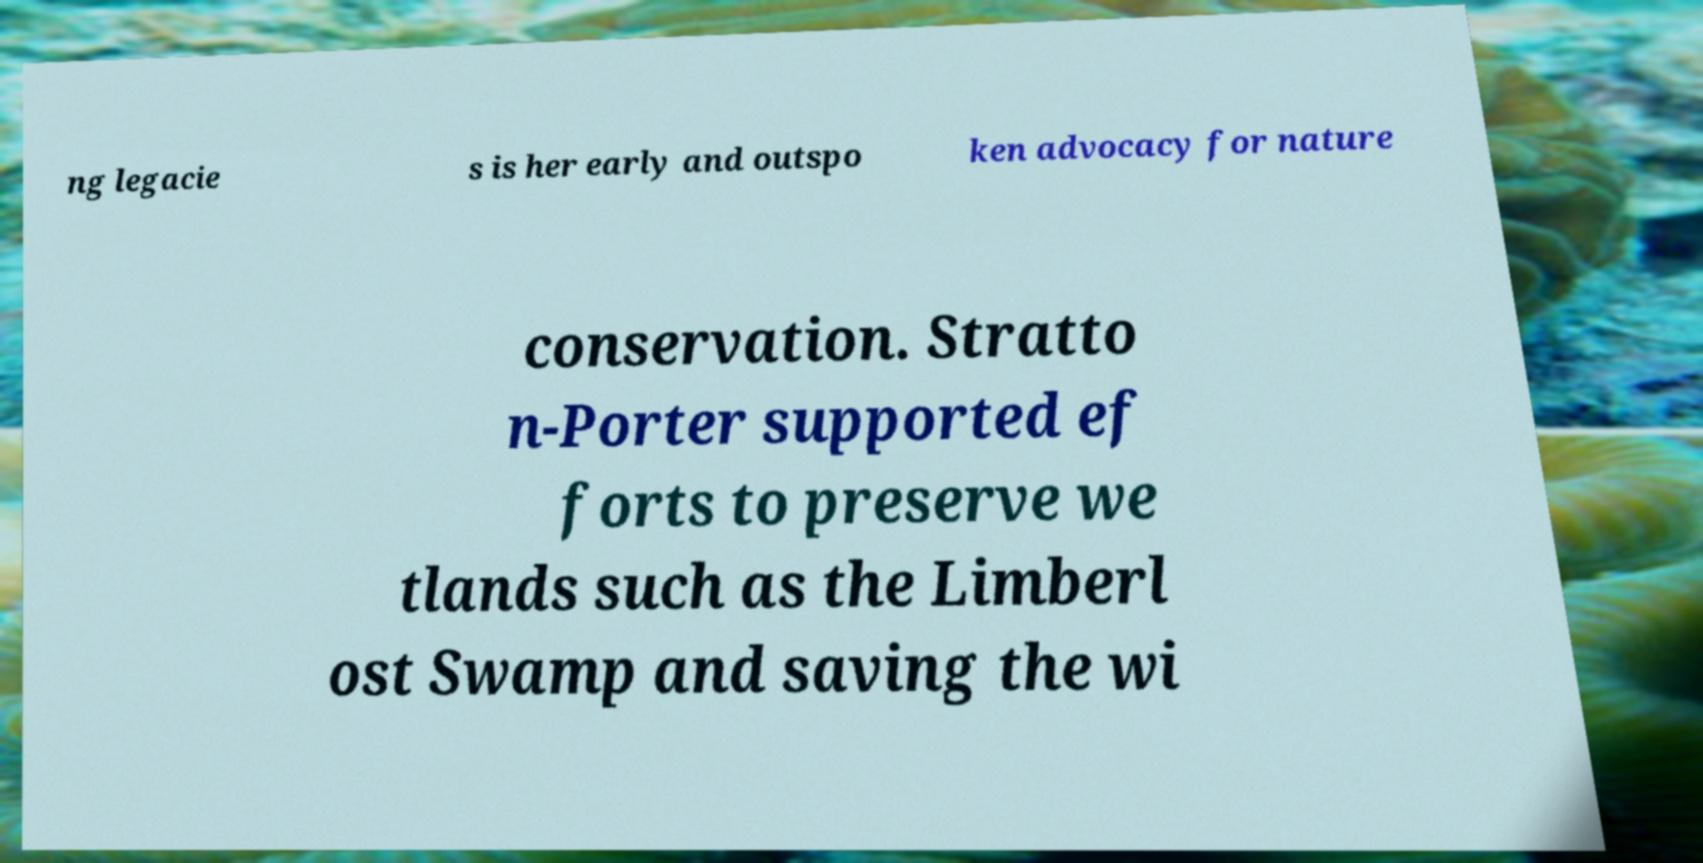For documentation purposes, I need the text within this image transcribed. Could you provide that? ng legacie s is her early and outspo ken advocacy for nature conservation. Stratto n-Porter supported ef forts to preserve we tlands such as the Limberl ost Swamp and saving the wi 